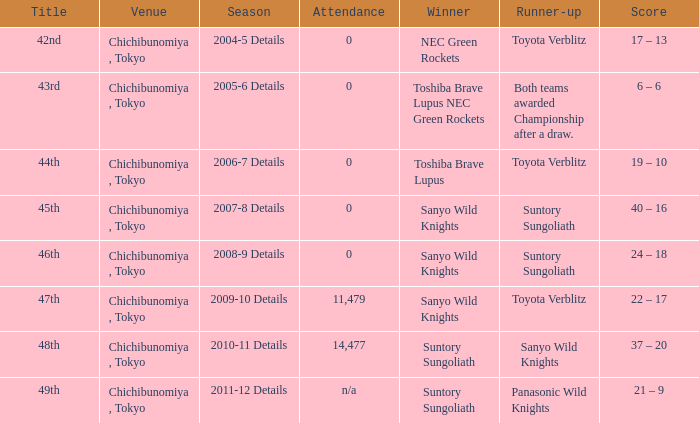What is the Score when the winner was sanyo wild knights, and a Runner-up of suntory sungoliath? 40 – 16, 24 – 18. 